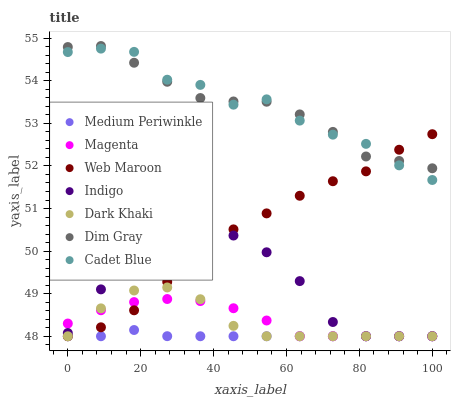Does Medium Periwinkle have the minimum area under the curve?
Answer yes or no. Yes. Does Cadet Blue have the maximum area under the curve?
Answer yes or no. Yes. Does Indigo have the minimum area under the curve?
Answer yes or no. No. Does Indigo have the maximum area under the curve?
Answer yes or no. No. Is Medium Periwinkle the smoothest?
Answer yes or no. Yes. Is Cadet Blue the roughest?
Answer yes or no. Yes. Is Indigo the smoothest?
Answer yes or no. No. Is Indigo the roughest?
Answer yes or no. No. Does Indigo have the lowest value?
Answer yes or no. Yes. Does Cadet Blue have the lowest value?
Answer yes or no. No. Does Dim Gray have the highest value?
Answer yes or no. Yes. Does Indigo have the highest value?
Answer yes or no. No. Is Medium Periwinkle less than Dim Gray?
Answer yes or no. Yes. Is Cadet Blue greater than Indigo?
Answer yes or no. Yes. Does Dark Khaki intersect Magenta?
Answer yes or no. Yes. Is Dark Khaki less than Magenta?
Answer yes or no. No. Is Dark Khaki greater than Magenta?
Answer yes or no. No. Does Medium Periwinkle intersect Dim Gray?
Answer yes or no. No. 